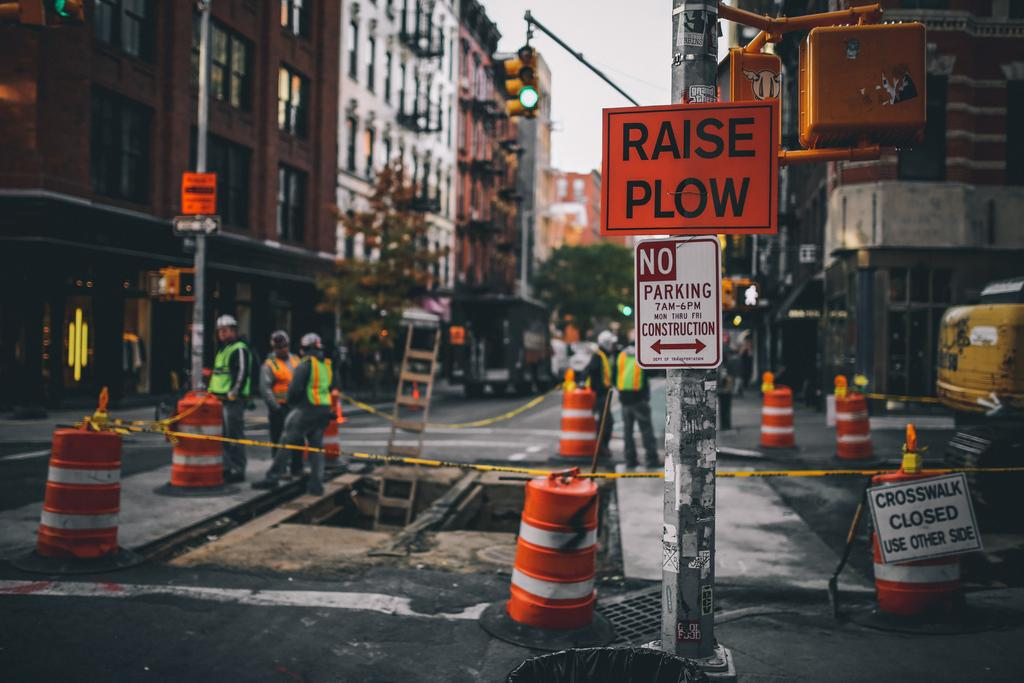<image>
Share a concise interpretation of the image provided. A orange and black raise plow sign is standing in front of a construction site. 